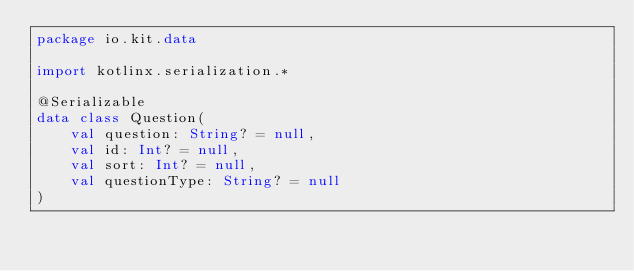Convert code to text. <code><loc_0><loc_0><loc_500><loc_500><_Kotlin_>package io.kit.data

import kotlinx.serialization.*

@Serializable
data class Question(
	val question: String? = null,
	val id: Int? = null,
	val sort: Int? = null,
	val questionType: String? = null
)
</code> 